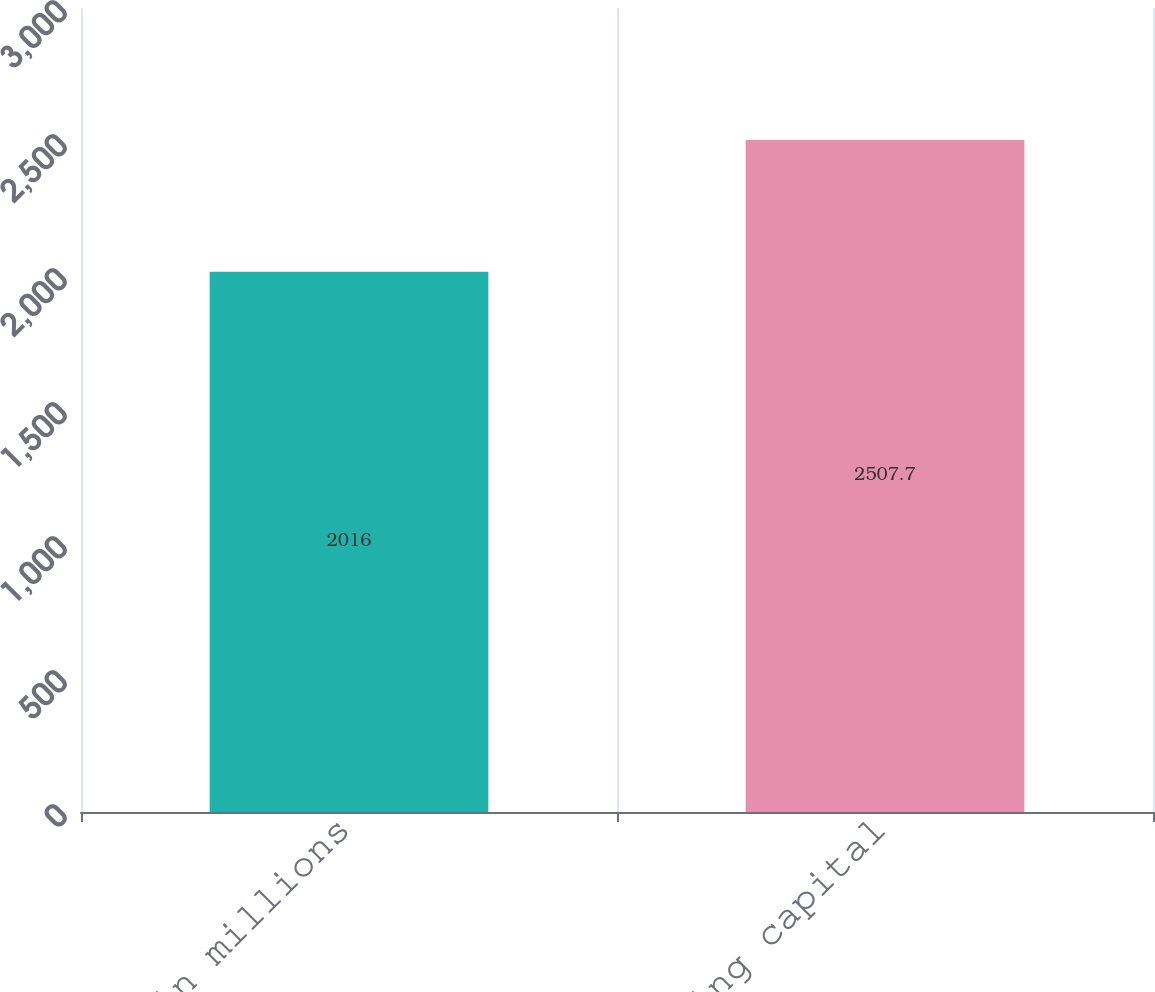Convert chart to OTSL. <chart><loc_0><loc_0><loc_500><loc_500><bar_chart><fcel>Dollars in millions<fcel>Working capital<nl><fcel>2016<fcel>2507.7<nl></chart> 